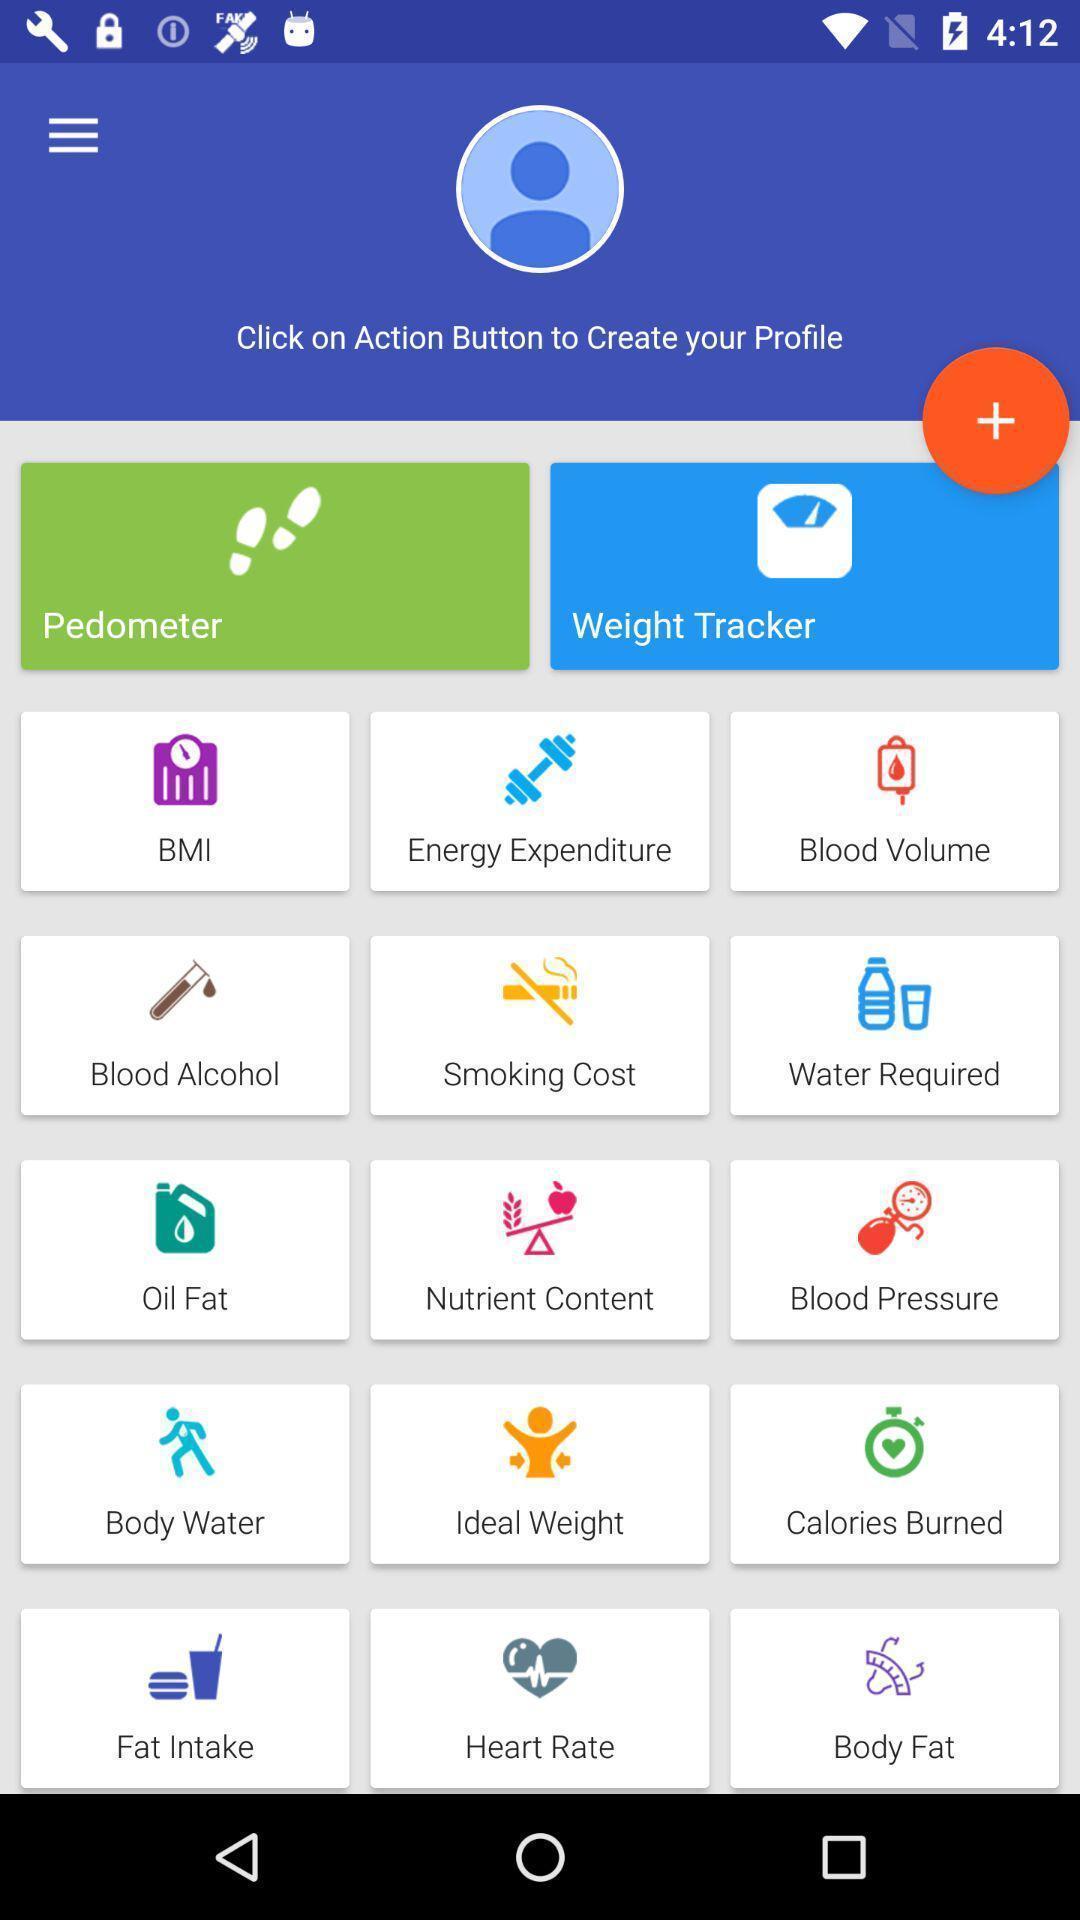Explain what's happening in this screen capture. Page shows information about a weight tracker. 